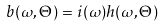<formula> <loc_0><loc_0><loc_500><loc_500>b ( \omega , \Theta ) = i ( \omega ) h ( \omega , \Theta )</formula> 